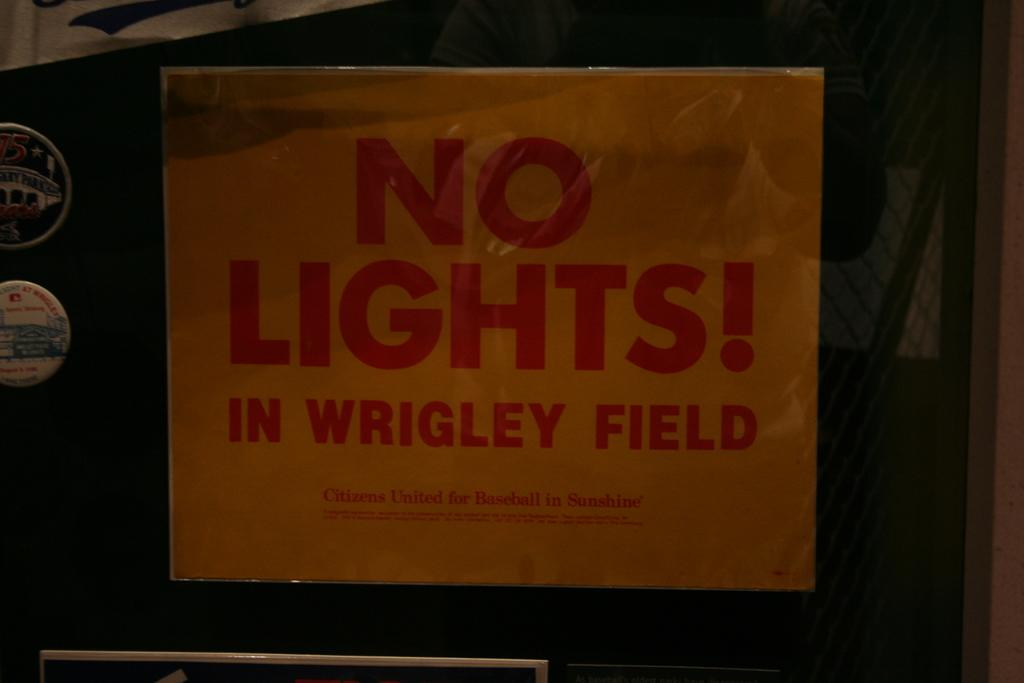What is attached to the mirror in the image? There is a paper pasted on a mirror in the image. What type of objects are present with pictures and text in the image? There are magnets with pictures and text in the image. Can you describe the mesh in the image? There is a mesh in the image, but no further details are provided. How many sheep can be seen grazing in the image? There are no sheep present in the image. What is the girl doing in the image? There is no girl present in the image. 